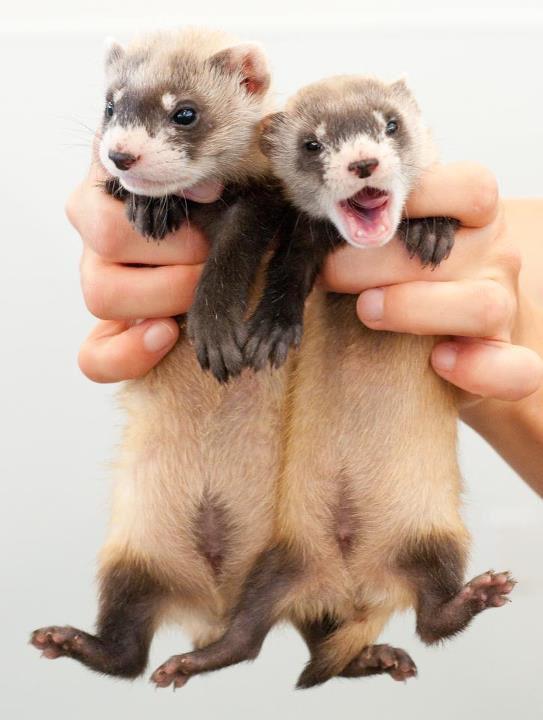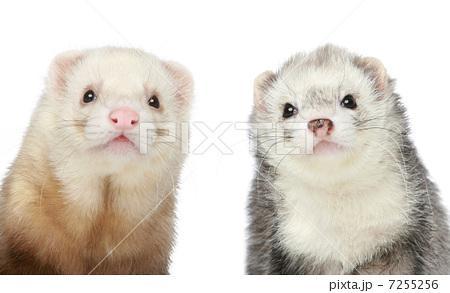The first image is the image on the left, the second image is the image on the right. Considering the images on both sides, is "Each image contains two ferrets, and one image shows hands holding up unclothed ferrets." valid? Answer yes or no. Yes. The first image is the image on the left, the second image is the image on the right. Analyze the images presented: Is the assertion "Two ferrets with the same fur color pattern are wearing clothes." valid? Answer yes or no. No. 